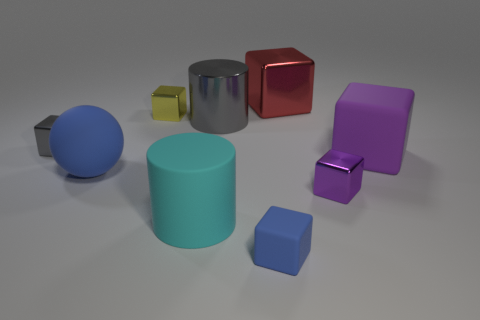Subtract all big purple cubes. How many cubes are left? 5 Subtract 1 cylinders. How many cylinders are left? 1 Subtract all cyan cylinders. How many cylinders are left? 1 Subtract all cylinders. How many objects are left? 7 Add 5 cylinders. How many cylinders exist? 7 Subtract 1 gray cylinders. How many objects are left? 8 Subtract all brown cubes. Subtract all green spheres. How many cubes are left? 6 Subtract all cyan balls. How many purple cylinders are left? 0 Subtract all matte blocks. Subtract all large blue spheres. How many objects are left? 6 Add 7 big red shiny things. How many big red shiny things are left? 8 